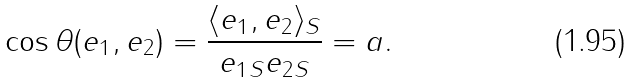Convert formula to latex. <formula><loc_0><loc_0><loc_500><loc_500>\cos \theta ( e _ { 1 } , e _ { 2 } ) = \frac { \langle e _ { 1 } , e _ { 2 } \rangle _ { S } } { \| e _ { 1 } \| _ { S } \| e _ { 2 } \| _ { S } } = a .</formula> 